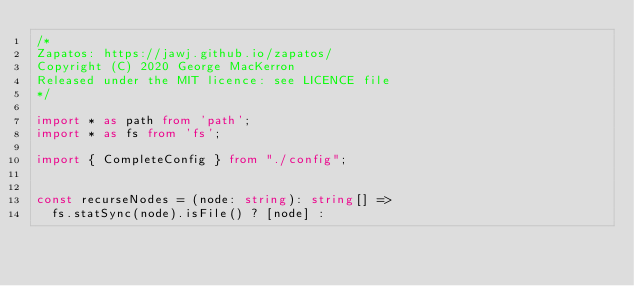<code> <loc_0><loc_0><loc_500><loc_500><_TypeScript_>/*
Zapatos: https://jawj.github.io/zapatos/
Copyright (C) 2020 George MacKerron
Released under the MIT licence: see LICENCE file
*/

import * as path from 'path';
import * as fs from 'fs';

import { CompleteConfig } from "./config";


const recurseNodes = (node: string): string[] =>
  fs.statSync(node).isFile() ? [node] :</code> 